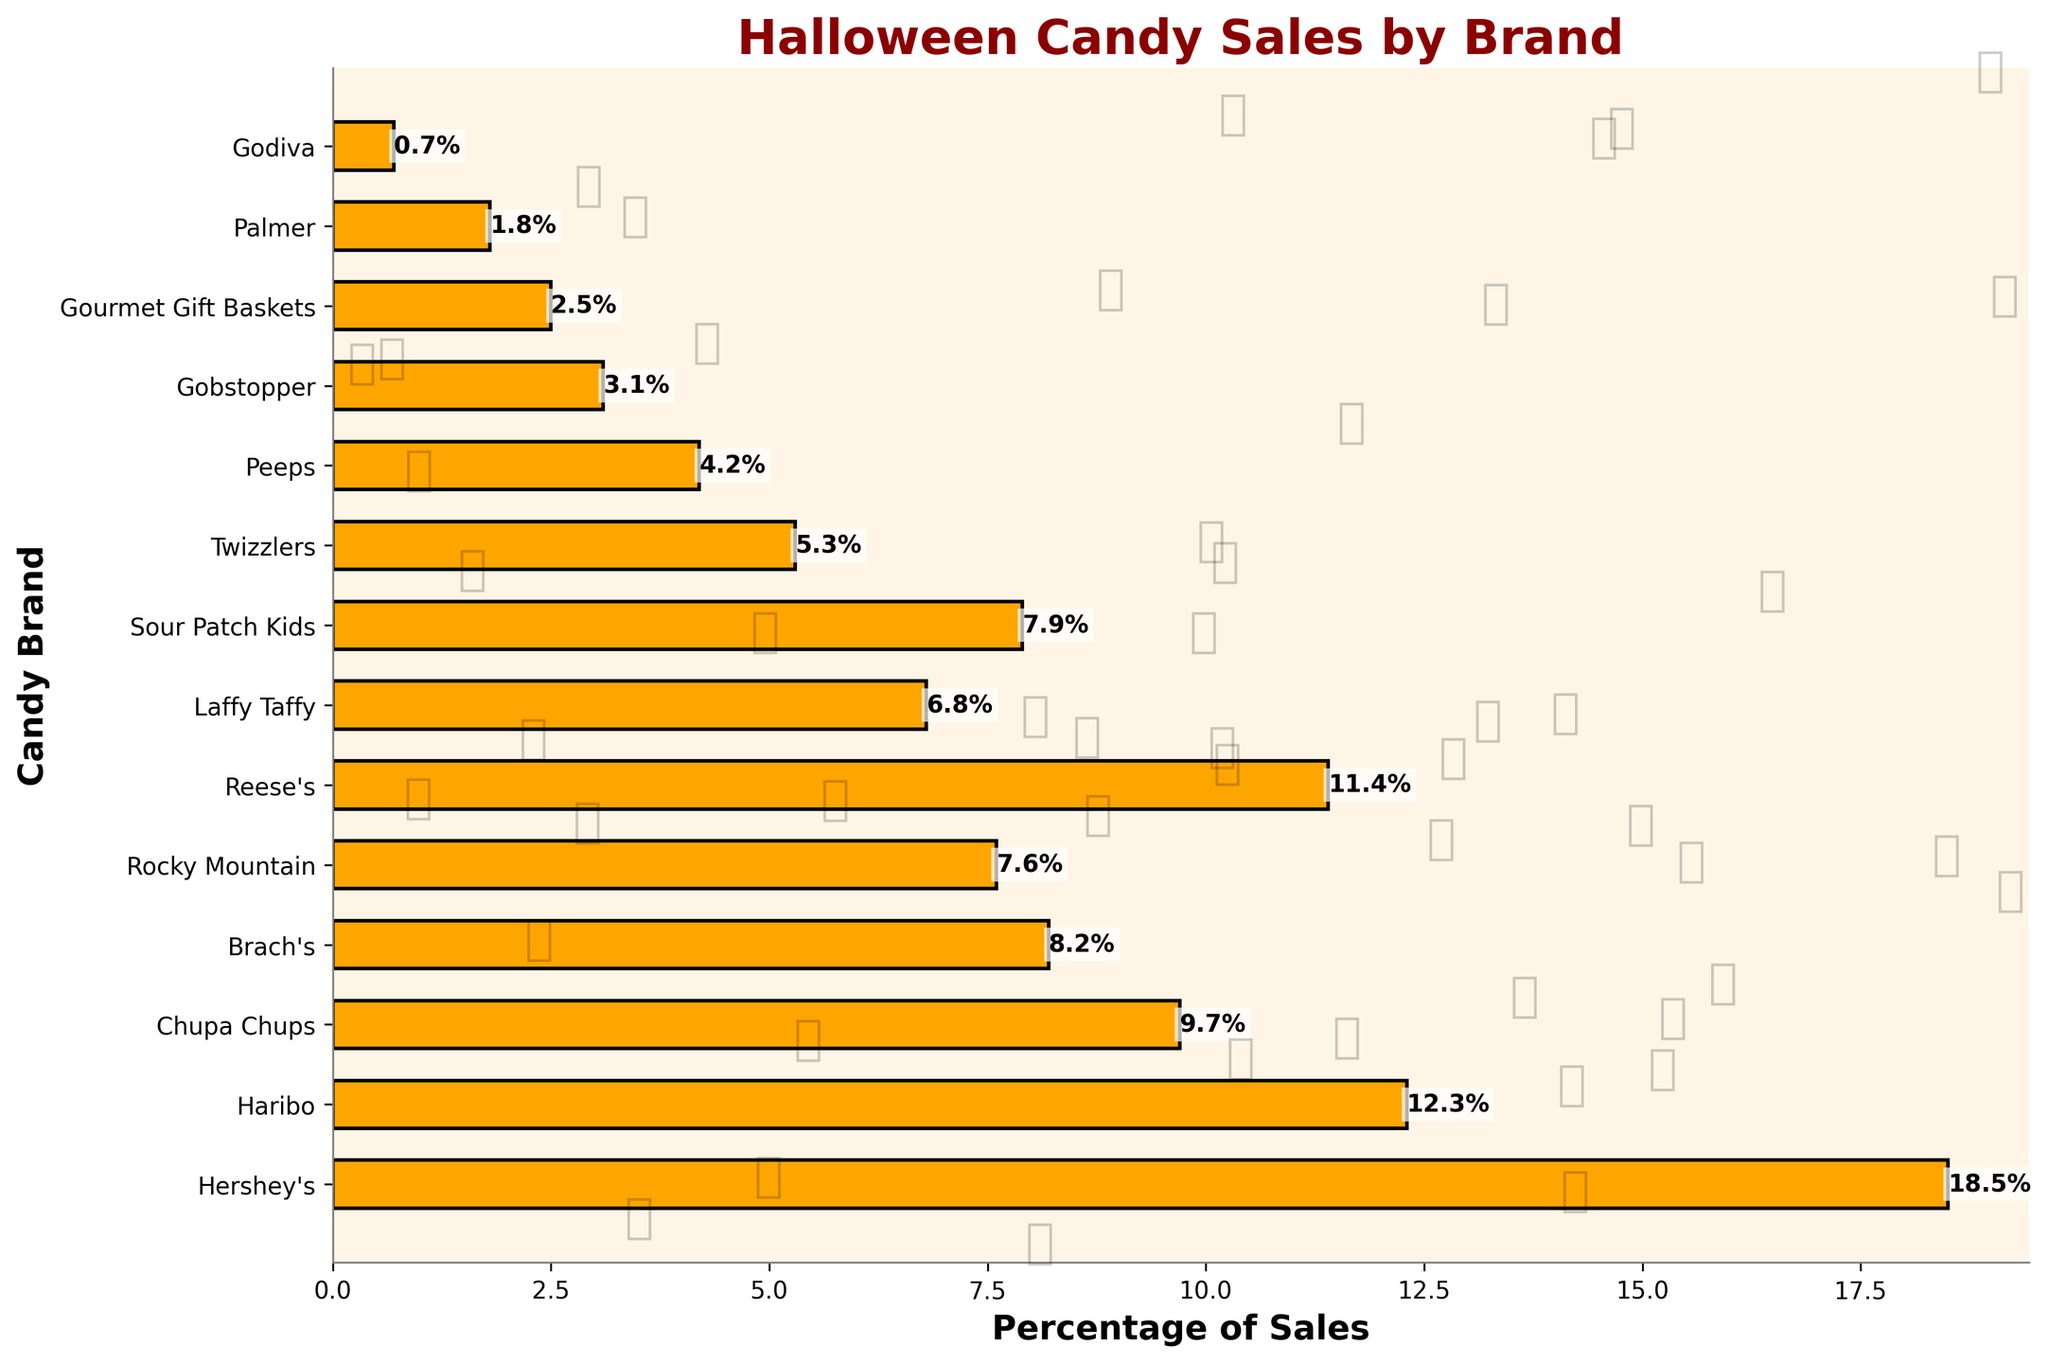Which brand has the highest percentage of Halloween candy sales? Look at the bar that extends the furthest to the right, which represents the highest percentage. That bar corresponds to Hershey's.
Answer: Hershey's Which two brands combined hold more than 30% of the sales? Look for two bars whose combined lengths add up to over 30%. Hershey's (18.5%) and Haribo (12.3%) together make 30.8%.
Answer: Hershey's and Haribo Are the combined sales percentages of Taffy and Licorice greater than or less than Gummy Candy sales? Add the percentages of Taffy (6.8%) and Licorice (5.3%), which equals 12.1%. Compare this with Gummy Candy's percentage (12.3%).
Answer: less than Which candy brand holds the smallest percentage of sales? Find the bar with the smallest length. The smallest bar represents Godiva with 0.7%.
Answer: Godiva What is the difference in sales percentages between Reese's Peanut Butter Cups and Laffy Taffy? Subtract the percentage of Laffy Taffy (6.8%) from the percentage of Reese's Peanut Butter Cups (11.4%): 11.4% - 6.8% = 4.6%.
Answer: 4.6% Between Sour Patch Kids and Rocky Mountain Caramel Apples, which has a higher percentage of sales? Compare the lengths of the bars corresponding to Sour Patch Kids (7.9%) and Rocky Mountain (7.6%).
Answer: Sour Patch Kids What is the total percentage of sales for candy brands with less than 5% of sales each? Add the percentages of Peeps (4.2%), Gobstopper (3.1%), Gourmet Gift Baskets (2.5%), Palmer (1.8%), and Godiva (0.7%): 4.2 + 3.1 + 2.5 + 1.8 + 0.7 = 12.3%.
Answer: 12.3% Which brand’s bar is positioned at the middle on the vertical axis? Identify the bar in the middle of the bar chart. The middle brand in the list is Reese's.
Answer: Reese's 